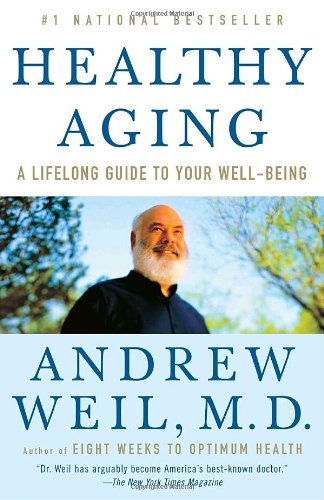Can you describe the physical appearance of the author from the cover? The author, Dr. Andrew Weil, appears on the cover with a calm and friendly demeanor, sporting a full white beard and a bald head. His image portrays a sense of wisdom and reliability. 